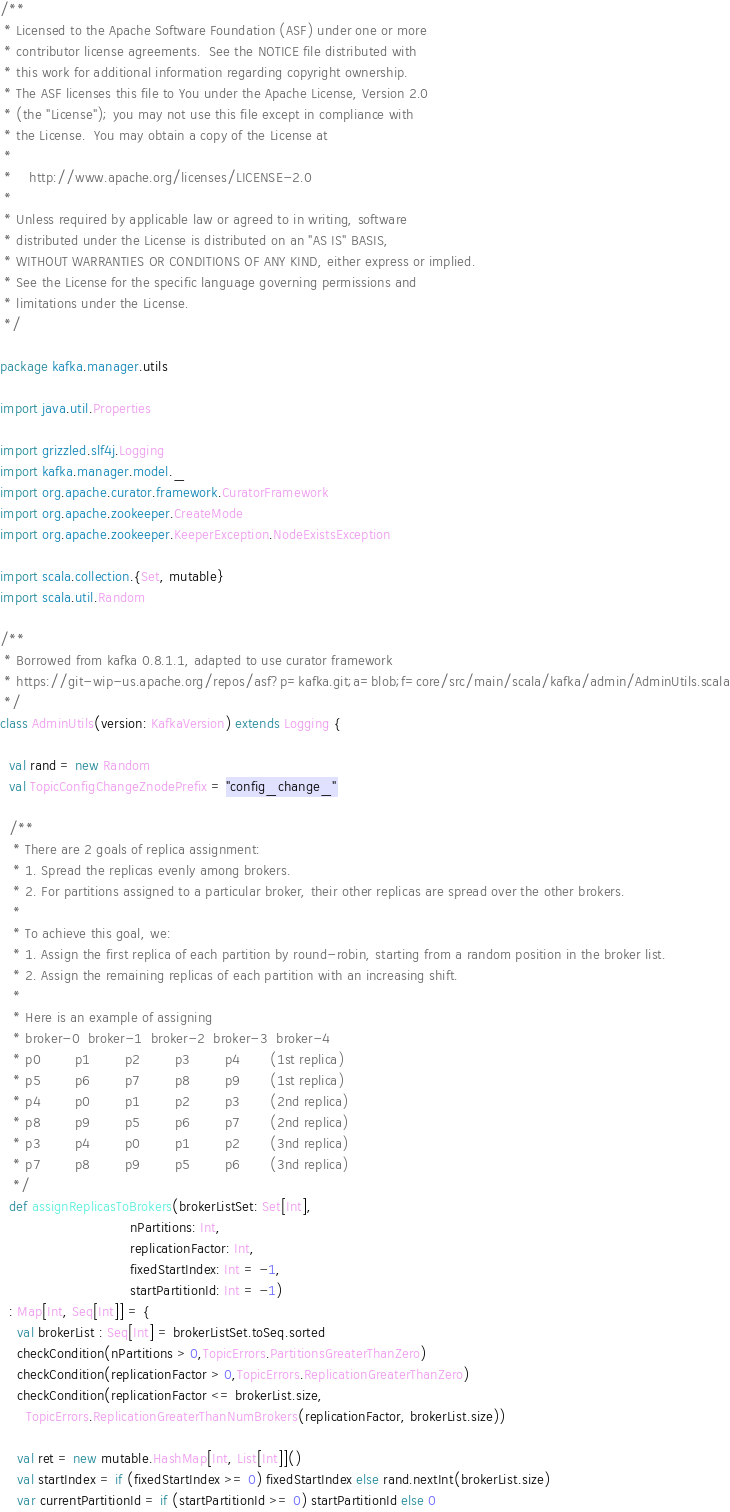Convert code to text. <code><loc_0><loc_0><loc_500><loc_500><_Scala_>/**
 * Licensed to the Apache Software Foundation (ASF) under one or more
 * contributor license agreements.  See the NOTICE file distributed with
 * this work for additional information regarding copyright ownership.
 * The ASF licenses this file to You under the Apache License, Version 2.0
 * (the "License"); you may not use this file except in compliance with
 * the License.  You may obtain a copy of the License at
 *
 *    http://www.apache.org/licenses/LICENSE-2.0
 *
 * Unless required by applicable law or agreed to in writing, software
 * distributed under the License is distributed on an "AS IS" BASIS,
 * WITHOUT WARRANTIES OR CONDITIONS OF ANY KIND, either express or implied.
 * See the License for the specific language governing permissions and
 * limitations under the License.
 */

package kafka.manager.utils

import java.util.Properties

import grizzled.slf4j.Logging
import kafka.manager.model._
import org.apache.curator.framework.CuratorFramework
import org.apache.zookeeper.CreateMode
import org.apache.zookeeper.KeeperException.NodeExistsException

import scala.collection.{Set, mutable}
import scala.util.Random

/**
 * Borrowed from kafka 0.8.1.1, adapted to use curator framework
 * https://git-wip-us.apache.org/repos/asf?p=kafka.git;a=blob;f=core/src/main/scala/kafka/admin/AdminUtils.scala
 */
class AdminUtils(version: KafkaVersion) extends Logging {

  val rand = new Random
  val TopicConfigChangeZnodePrefix = "config_change_"

  /**
   * There are 2 goals of replica assignment:
   * 1. Spread the replicas evenly among brokers.
   * 2. For partitions assigned to a particular broker, their other replicas are spread over the other brokers.
   *
   * To achieve this goal, we:
   * 1. Assign the first replica of each partition by round-robin, starting from a random position in the broker list.
   * 2. Assign the remaining replicas of each partition with an increasing shift.
   *
   * Here is an example of assigning
   * broker-0  broker-1  broker-2  broker-3  broker-4
   * p0        p1        p2        p3        p4       (1st replica)
   * p5        p6        p7        p8        p9       (1st replica)
   * p4        p0        p1        p2        p3       (2nd replica)
   * p8        p9        p5        p6        p7       (2nd replica)
   * p3        p4        p0        p1        p2       (3nd replica)
   * p7        p8        p9        p5        p6       (3nd replica)
   */
  def assignReplicasToBrokers(brokerListSet: Set[Int],
                              nPartitions: Int,
                              replicationFactor: Int,
                              fixedStartIndex: Int = -1,
                              startPartitionId: Int = -1)
  : Map[Int, Seq[Int]] = {
    val brokerList : Seq[Int] = brokerListSet.toSeq.sorted
    checkCondition(nPartitions > 0,TopicErrors.PartitionsGreaterThanZero)
    checkCondition(replicationFactor > 0,TopicErrors.ReplicationGreaterThanZero)
    checkCondition(replicationFactor <= brokerList.size,
      TopicErrors.ReplicationGreaterThanNumBrokers(replicationFactor, brokerList.size))

    val ret = new mutable.HashMap[Int, List[Int]]()
    val startIndex = if (fixedStartIndex >= 0) fixedStartIndex else rand.nextInt(brokerList.size)
    var currentPartitionId = if (startPartitionId >= 0) startPartitionId else 0
</code> 